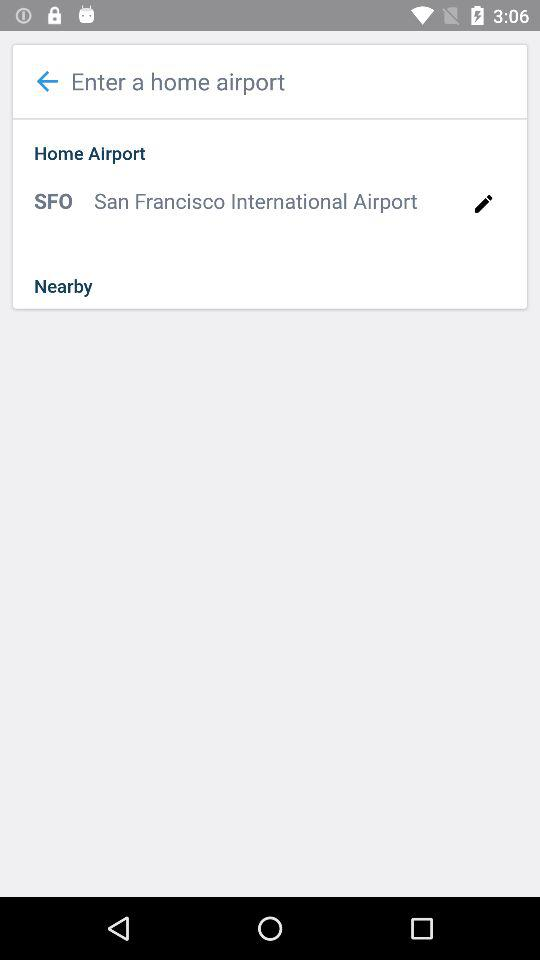What is the name of the airport? The name of the airport is San Francisco International Airport. 